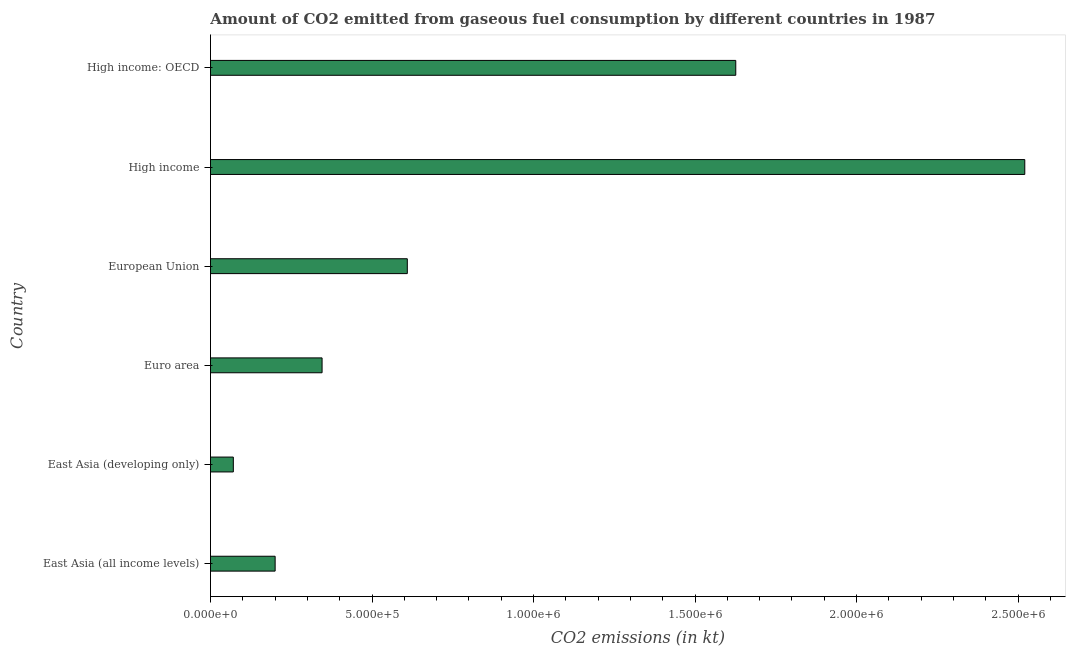What is the title of the graph?
Provide a succinct answer. Amount of CO2 emitted from gaseous fuel consumption by different countries in 1987. What is the label or title of the X-axis?
Give a very brief answer. CO2 emissions (in kt). What is the label or title of the Y-axis?
Offer a very short reply. Country. What is the co2 emissions from gaseous fuel consumption in High income?
Give a very brief answer. 2.52e+06. Across all countries, what is the maximum co2 emissions from gaseous fuel consumption?
Offer a terse response. 2.52e+06. Across all countries, what is the minimum co2 emissions from gaseous fuel consumption?
Provide a succinct answer. 7.07e+04. In which country was the co2 emissions from gaseous fuel consumption maximum?
Provide a short and direct response. High income. In which country was the co2 emissions from gaseous fuel consumption minimum?
Your response must be concise. East Asia (developing only). What is the sum of the co2 emissions from gaseous fuel consumption?
Offer a terse response. 5.37e+06. What is the difference between the co2 emissions from gaseous fuel consumption in East Asia (all income levels) and High income?
Your answer should be very brief. -2.32e+06. What is the average co2 emissions from gaseous fuel consumption per country?
Provide a short and direct response. 8.95e+05. What is the median co2 emissions from gaseous fuel consumption?
Give a very brief answer. 4.77e+05. In how many countries, is the co2 emissions from gaseous fuel consumption greater than 1000000 kt?
Ensure brevity in your answer.  2. What is the ratio of the co2 emissions from gaseous fuel consumption in East Asia (all income levels) to that in Euro area?
Make the answer very short. 0.58. What is the difference between the highest and the second highest co2 emissions from gaseous fuel consumption?
Provide a succinct answer. 8.95e+05. Is the sum of the co2 emissions from gaseous fuel consumption in East Asia (all income levels) and High income greater than the maximum co2 emissions from gaseous fuel consumption across all countries?
Keep it short and to the point. Yes. What is the difference between the highest and the lowest co2 emissions from gaseous fuel consumption?
Give a very brief answer. 2.45e+06. How many bars are there?
Make the answer very short. 6. Are all the bars in the graph horizontal?
Your answer should be compact. Yes. What is the difference between two consecutive major ticks on the X-axis?
Your answer should be compact. 5.00e+05. What is the CO2 emissions (in kt) in East Asia (all income levels)?
Offer a very short reply. 2.00e+05. What is the CO2 emissions (in kt) of East Asia (developing only)?
Your answer should be compact. 7.07e+04. What is the CO2 emissions (in kt) in Euro area?
Provide a succinct answer. 3.45e+05. What is the CO2 emissions (in kt) in European Union?
Offer a very short reply. 6.09e+05. What is the CO2 emissions (in kt) in High income?
Make the answer very short. 2.52e+06. What is the CO2 emissions (in kt) of High income: OECD?
Keep it short and to the point. 1.63e+06. What is the difference between the CO2 emissions (in kt) in East Asia (all income levels) and East Asia (developing only)?
Give a very brief answer. 1.29e+05. What is the difference between the CO2 emissions (in kt) in East Asia (all income levels) and Euro area?
Your response must be concise. -1.45e+05. What is the difference between the CO2 emissions (in kt) in East Asia (all income levels) and European Union?
Offer a terse response. -4.09e+05. What is the difference between the CO2 emissions (in kt) in East Asia (all income levels) and High income?
Your answer should be very brief. -2.32e+06. What is the difference between the CO2 emissions (in kt) in East Asia (all income levels) and High income: OECD?
Ensure brevity in your answer.  -1.43e+06. What is the difference between the CO2 emissions (in kt) in East Asia (developing only) and Euro area?
Make the answer very short. -2.75e+05. What is the difference between the CO2 emissions (in kt) in East Asia (developing only) and European Union?
Provide a short and direct response. -5.39e+05. What is the difference between the CO2 emissions (in kt) in East Asia (developing only) and High income?
Provide a succinct answer. -2.45e+06. What is the difference between the CO2 emissions (in kt) in East Asia (developing only) and High income: OECD?
Your answer should be compact. -1.56e+06. What is the difference between the CO2 emissions (in kt) in Euro area and European Union?
Keep it short and to the point. -2.64e+05. What is the difference between the CO2 emissions (in kt) in Euro area and High income?
Your answer should be very brief. -2.18e+06. What is the difference between the CO2 emissions (in kt) in Euro area and High income: OECD?
Provide a succinct answer. -1.28e+06. What is the difference between the CO2 emissions (in kt) in European Union and High income?
Your answer should be compact. -1.91e+06. What is the difference between the CO2 emissions (in kt) in European Union and High income: OECD?
Your answer should be compact. -1.02e+06. What is the difference between the CO2 emissions (in kt) in High income and High income: OECD?
Offer a terse response. 8.95e+05. What is the ratio of the CO2 emissions (in kt) in East Asia (all income levels) to that in East Asia (developing only)?
Offer a terse response. 2.83. What is the ratio of the CO2 emissions (in kt) in East Asia (all income levels) to that in Euro area?
Your answer should be compact. 0.58. What is the ratio of the CO2 emissions (in kt) in East Asia (all income levels) to that in European Union?
Offer a very short reply. 0.33. What is the ratio of the CO2 emissions (in kt) in East Asia (all income levels) to that in High income?
Make the answer very short. 0.08. What is the ratio of the CO2 emissions (in kt) in East Asia (all income levels) to that in High income: OECD?
Provide a short and direct response. 0.12. What is the ratio of the CO2 emissions (in kt) in East Asia (developing only) to that in Euro area?
Provide a short and direct response. 0.2. What is the ratio of the CO2 emissions (in kt) in East Asia (developing only) to that in European Union?
Make the answer very short. 0.12. What is the ratio of the CO2 emissions (in kt) in East Asia (developing only) to that in High income?
Keep it short and to the point. 0.03. What is the ratio of the CO2 emissions (in kt) in East Asia (developing only) to that in High income: OECD?
Give a very brief answer. 0.04. What is the ratio of the CO2 emissions (in kt) in Euro area to that in European Union?
Give a very brief answer. 0.57. What is the ratio of the CO2 emissions (in kt) in Euro area to that in High income?
Offer a terse response. 0.14. What is the ratio of the CO2 emissions (in kt) in Euro area to that in High income: OECD?
Your response must be concise. 0.21. What is the ratio of the CO2 emissions (in kt) in European Union to that in High income?
Offer a terse response. 0.24. What is the ratio of the CO2 emissions (in kt) in European Union to that in High income: OECD?
Give a very brief answer. 0.38. What is the ratio of the CO2 emissions (in kt) in High income to that in High income: OECD?
Offer a terse response. 1.55. 